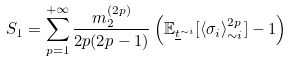Convert formula to latex. <formula><loc_0><loc_0><loc_500><loc_500>S _ { 1 } = \sum _ { p = 1 } ^ { + \infty } \frac { m _ { 2 } ^ { ( 2 p ) } } { 2 p ( 2 p - 1 ) } \left ( \mathbb { E } _ { \underline { t } ^ { \sim i } } [ \langle \sigma _ { i } \rangle _ { \sim i } ^ { 2 p } ] - 1 \right )</formula> 